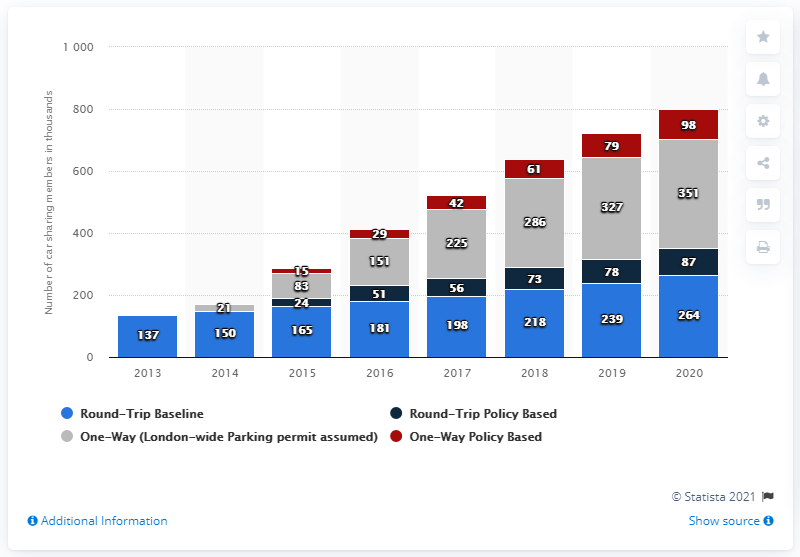Highlight a few significant elements in this photo. One-way policy-based mechanisms may represent the color red. The highest projected number is 351. 